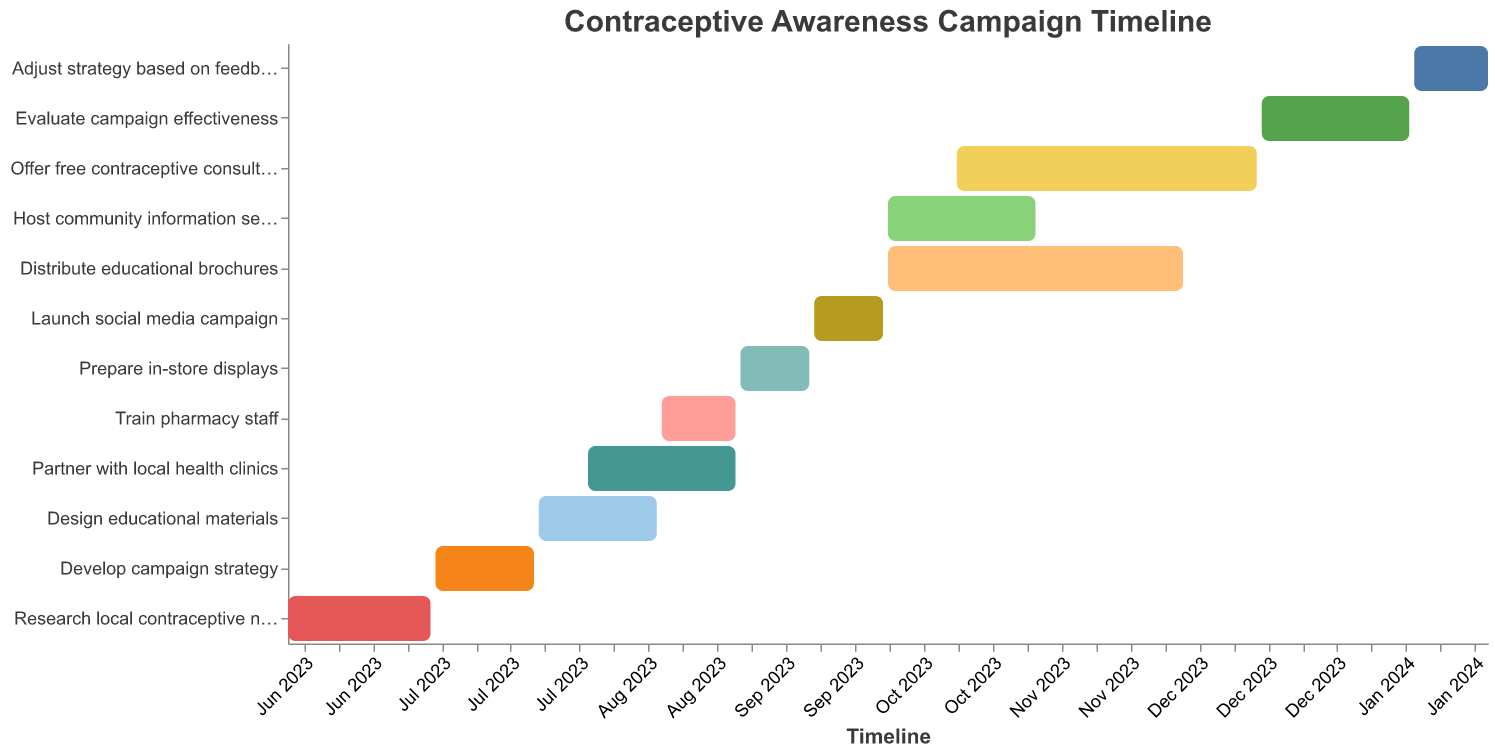What is the duration for developing the campaign strategy? The development of the campaign strategy starts on July 1, 2023, and ends on July 21, 2023. The total duration is (21 - 1) + 1 days = 21 days.
Answer: 21 days Which tasks are scheduled to occur entirely in August 2023? The tasks that are scheduled entirely in August 2023 are "Partner with local health clinics" (August 1-31) and "Train pharmacy staff" (August 16-31).
Answer: Partner with local health clinics, Train pharmacy staff How long is the longest task in the campaign? To determine the longest task, check the duration of each task: “Distribute educational brochures” (October 1 to November 30) lasts for 61 days.
Answer: 61 days When does the task "Offer free contraceptive consultations" start? "Offer free contraceptive consultations" starts on October 15, 2023.
Answer: October 15, 2023 Which task ends first in the timeline? By examining the timeline, "Research local contraceptive needs" ends first on June 30, 2023.
Answer: Research local contraceptive needs How many tasks overlap with "Design educational materials"? "Design educational materials" runs from July 22, 2023, to August 15, 2023. The overlapping tasks are "Develop campaign strategy" (July 1-21 overlaps until July 21), "Partner with local health clinics" (August 1-31 overlaps from August 1 to 15), and "Train pharmacy staff" (August 16-31 starts just one day after "Design educational materials" ends, so it slightly overlaps in planning). Thus, there are 2 overlapping tasks.
Answer: 2 tasks Which tasks are ongoing during October 2023? The tasks ongoing in October 2023 are "Host community information sessions" (October 1-31), "Distribute educational brochures" (October 1-November 30), and "Offer free contraceptive consultations" (October 15-December 15).
Answer: Host community information sessions, Distribute educational brochures, Offer free contraceptive consultations What’s the total duration from the start of the first task to the end of the last task? The campaign starts with "Research local contraceptive needs" on June 1, 2023, and ends with "Adjust strategy based on feedback" on January 31, 2024. Total duration = (January 31, 2024 - June 1, 2023) = 245 days.
Answer: 245 days 